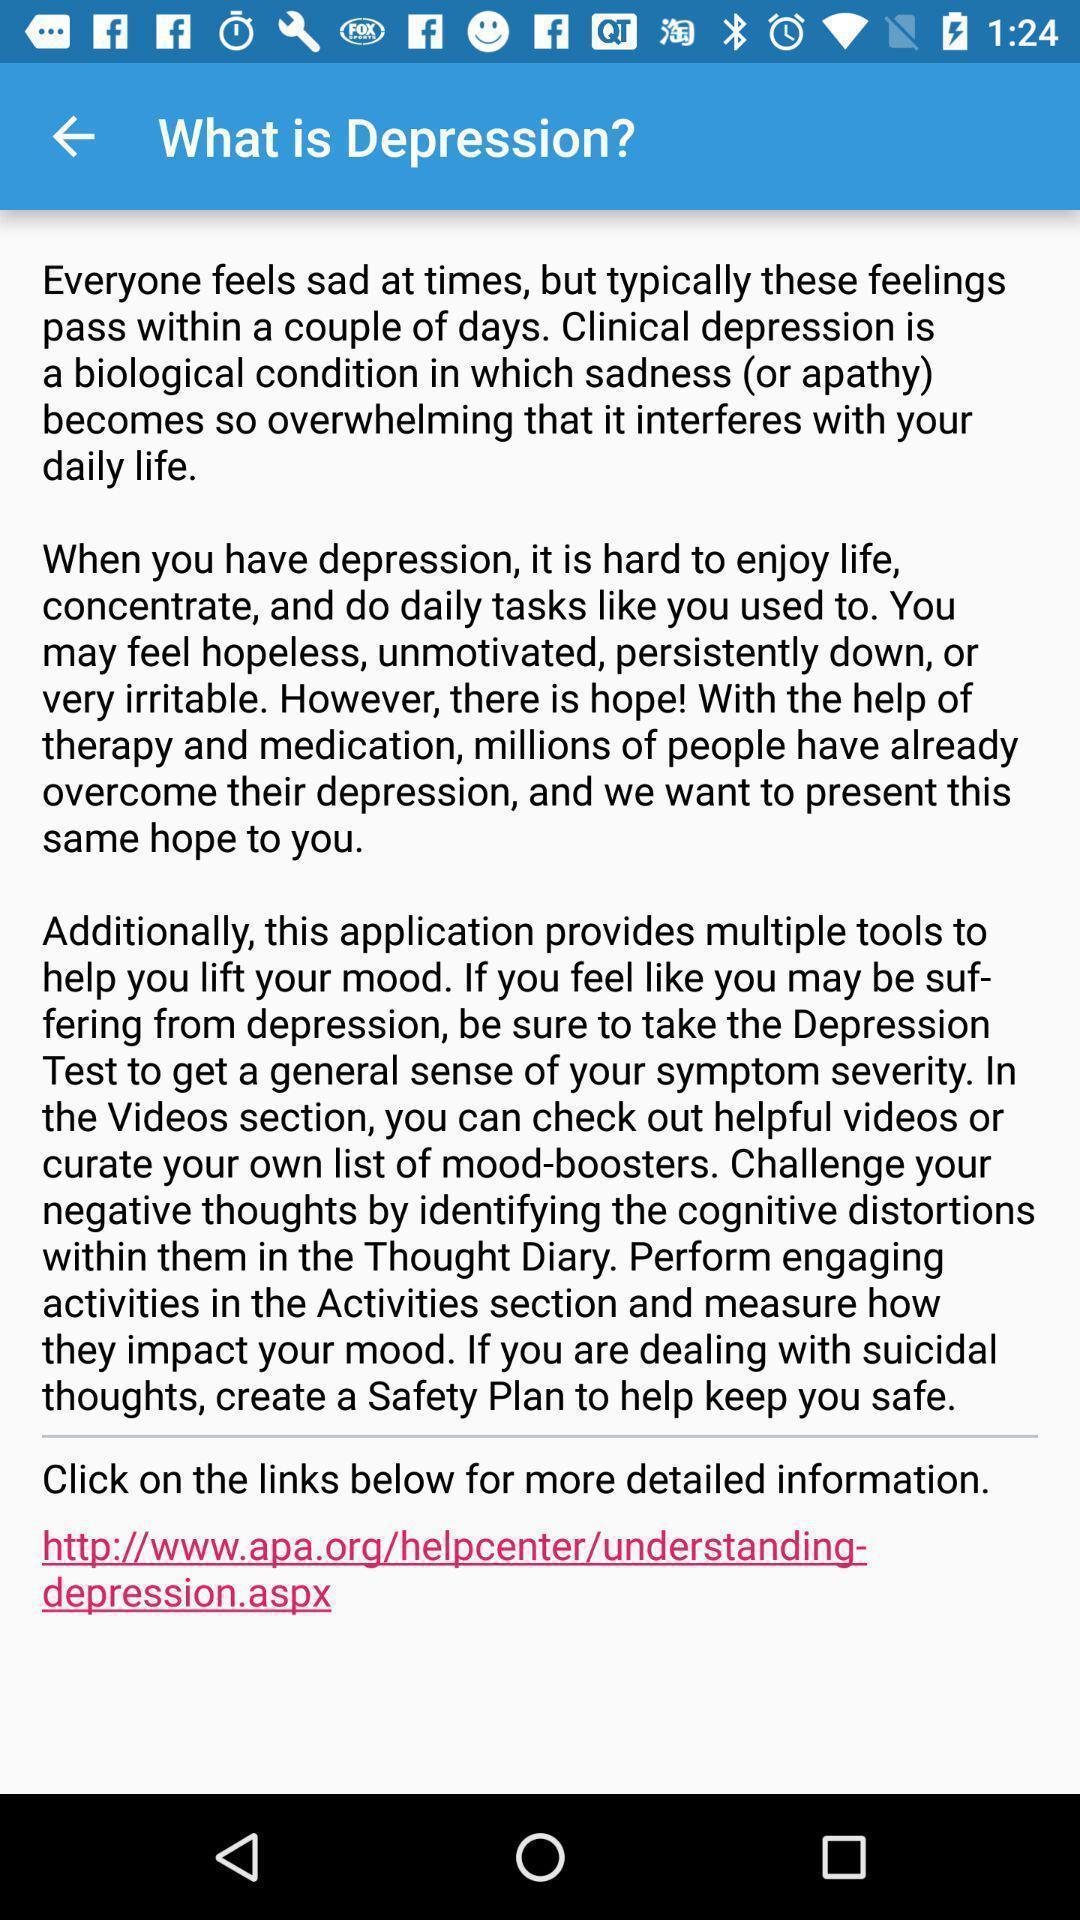Explain what's happening in this screen capture. Screen displaying the answer of a question. 